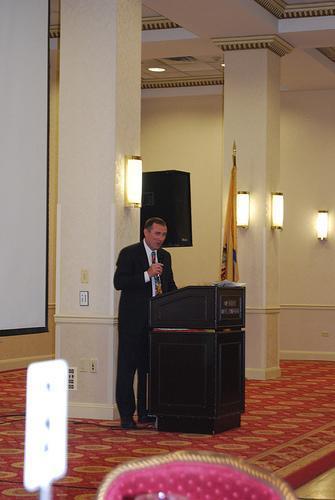How many men are there?
Give a very brief answer. 1. 